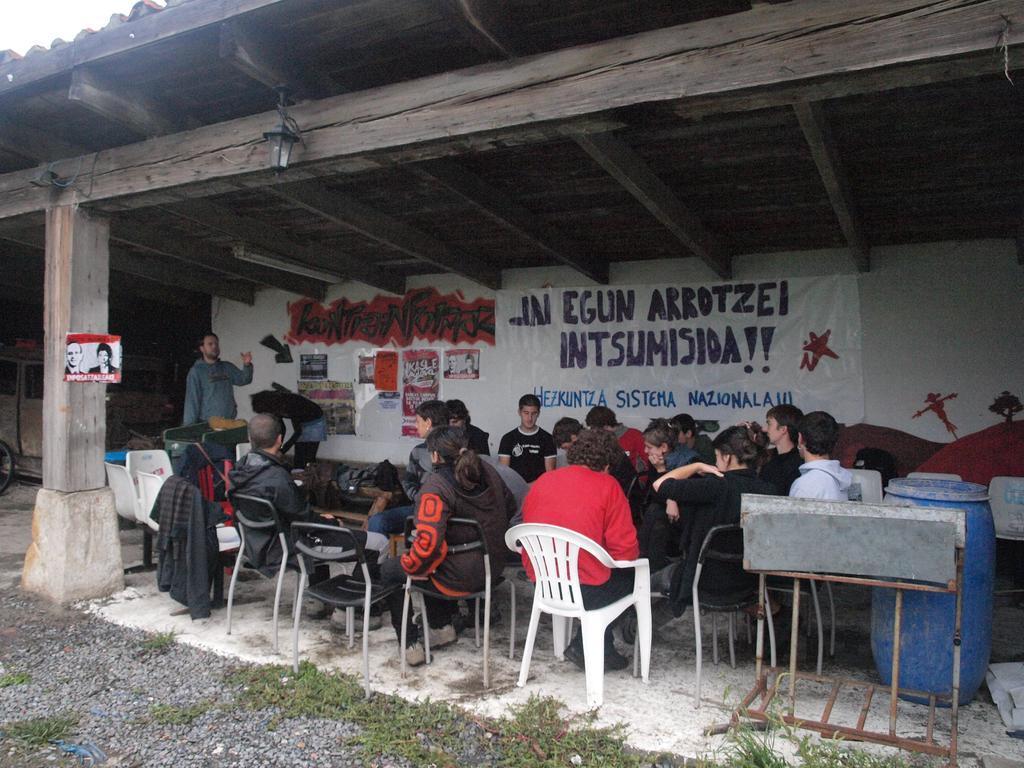How would you summarize this image in a sentence or two? As we can see in the image there is a wall, banner, few people sitting on chairs and there is a table and on the right side there is a drum. 